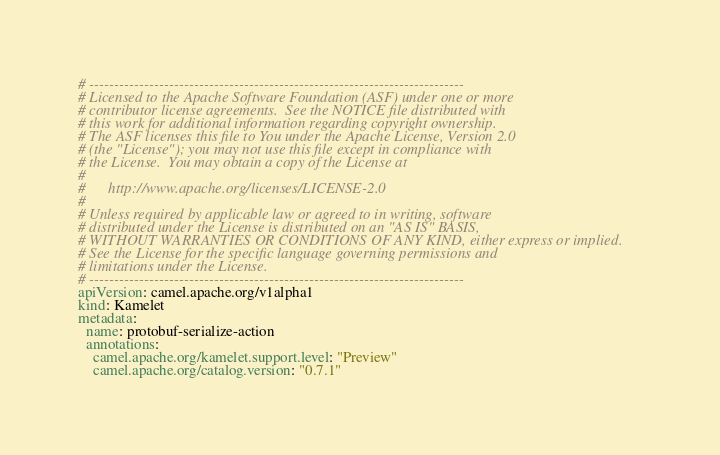<code> <loc_0><loc_0><loc_500><loc_500><_YAML_># ---------------------------------------------------------------------------
# Licensed to the Apache Software Foundation (ASF) under one or more
# contributor license agreements.  See the NOTICE file distributed with
# this work for additional information regarding copyright ownership.
# The ASF licenses this file to You under the Apache License, Version 2.0
# (the "License"); you may not use this file except in compliance with
# the License.  You may obtain a copy of the License at
#
#      http://www.apache.org/licenses/LICENSE-2.0
#
# Unless required by applicable law or agreed to in writing, software
# distributed under the License is distributed on an "AS IS" BASIS,
# WITHOUT WARRANTIES OR CONDITIONS OF ANY KIND, either express or implied.
# See the License for the specific language governing permissions and
# limitations under the License.
# ---------------------------------------------------------------------------
apiVersion: camel.apache.org/v1alpha1
kind: Kamelet
metadata:
  name: protobuf-serialize-action
  annotations:
    camel.apache.org/kamelet.support.level: "Preview"
    camel.apache.org/catalog.version: "0.7.1"</code> 